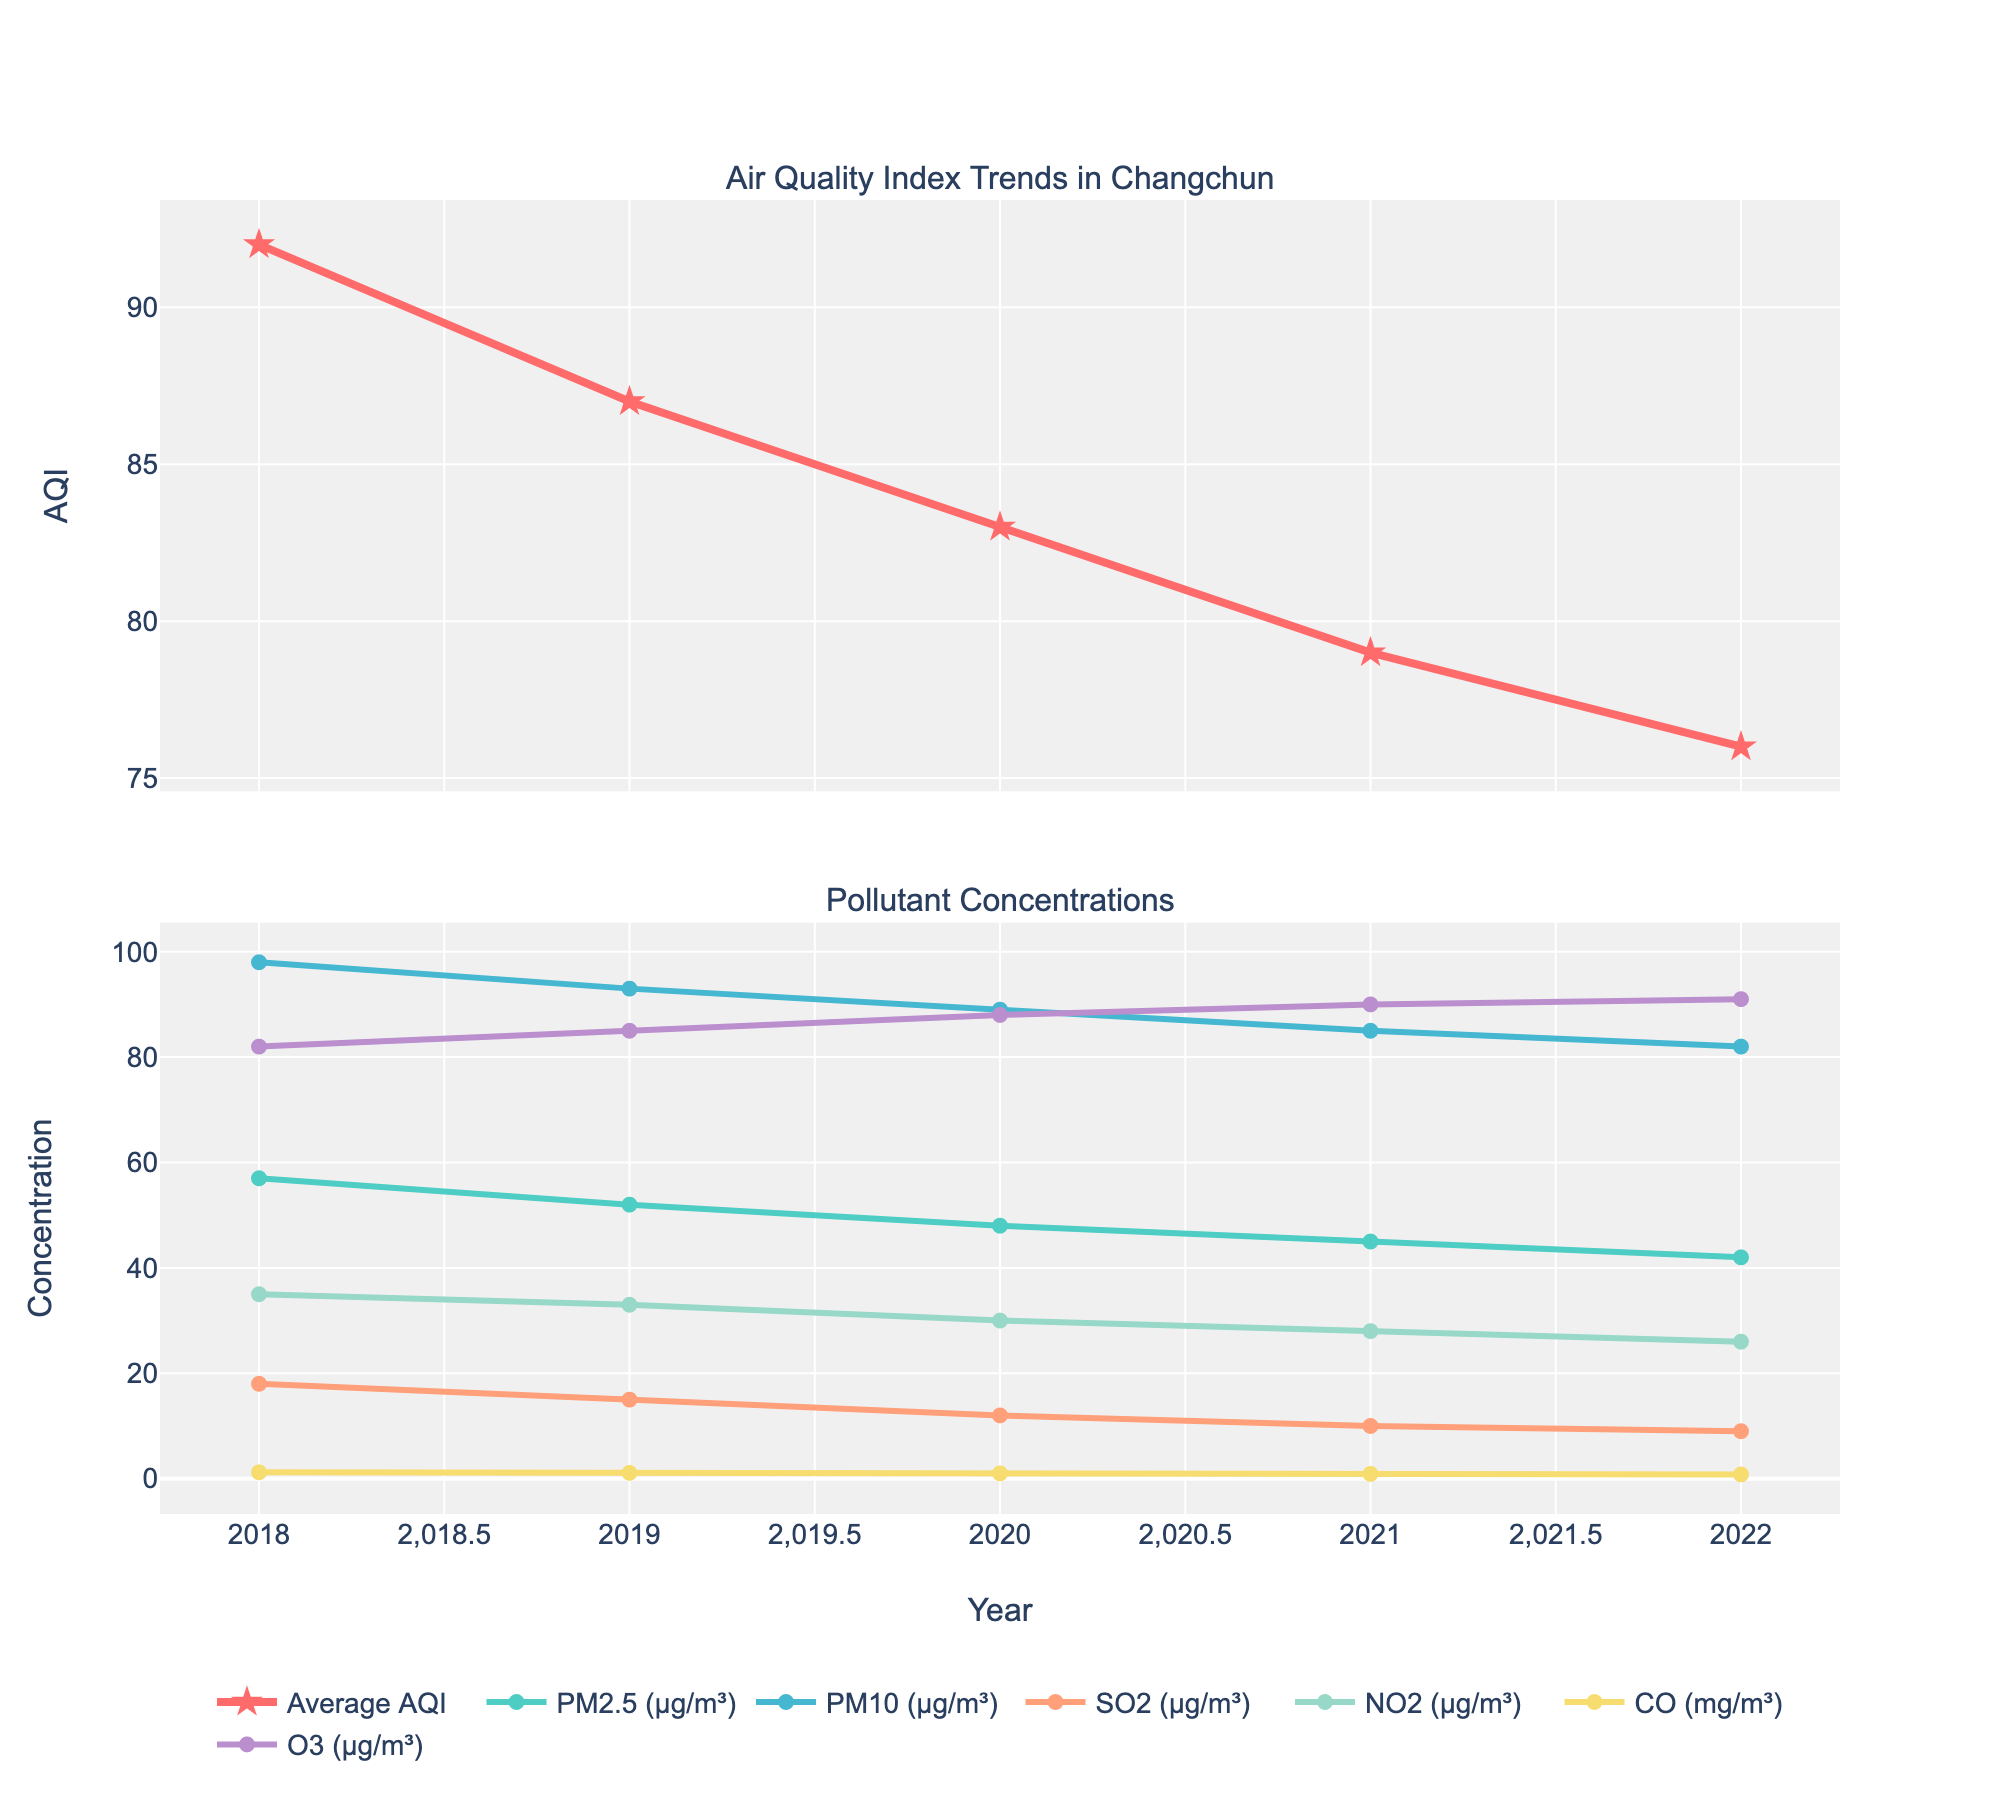What's the trend in the average AQI from 2018 to 2022? The average AQI is represented by a line with markers in the upper subplot. Observing this line, we notice that it decreases over the years from 92 in 2018 to 76 in 2022.
Answer: Decreasing How does the concentration of PM2.5 change over the years? The concentration of PM2.5 is represented by a line with markers in the lower subplot. From 2018 to 2022, the levels drop steadily from 57 μg/m³ to 42 μg/m³.
Answer: Decreasing Which pollutant has the highest concentration in 2022? In the lower subplot for 2022, the pollutant with the highest concentration line near the top is PM10 at 82 μg/m³.
Answer: PM10 Was PM10's concentration higher in 2019 or 2021? Examining the PM10 line in the lower subplot, its concentration was 93 μg/m³ in 2019 and 85 μg/m³ in 2021. Hence, it was higher in 2019.
Answer: 2019 By how many units did the concentration of SO2 decrease from 2018 to 2022? The line for SO2 in the lower subplot shows concentrations reducing from 18 μg/m³ in 2018 to 9 μg/m³ in 2022. The difference is 18 - 9 = 9 units.
Answer: 9 units Which pollutant showed the least change in concentration over the five years? We compare the endpoints of each pollutant's line in the lower subplot. O3's concentration changed from 82 μg/m³ in 2018 to 91 μg/m³ in 2022, which is the smallest relative change.
Answer: O3 Compare the trends of NO2 and CO concentrations. How do they differ? The NO2 line shows a steady decrease from 35 μg/m³ in 2018 to 26 μg/m³ in 2022. The CO line also shows a decrease but from 1.2 mg/m³ to 0.8 mg/m³. Both decrease, but NO2 starts higher and has larger numerical reductions.
Answer: Both decrease, NO2 has larger reduction 